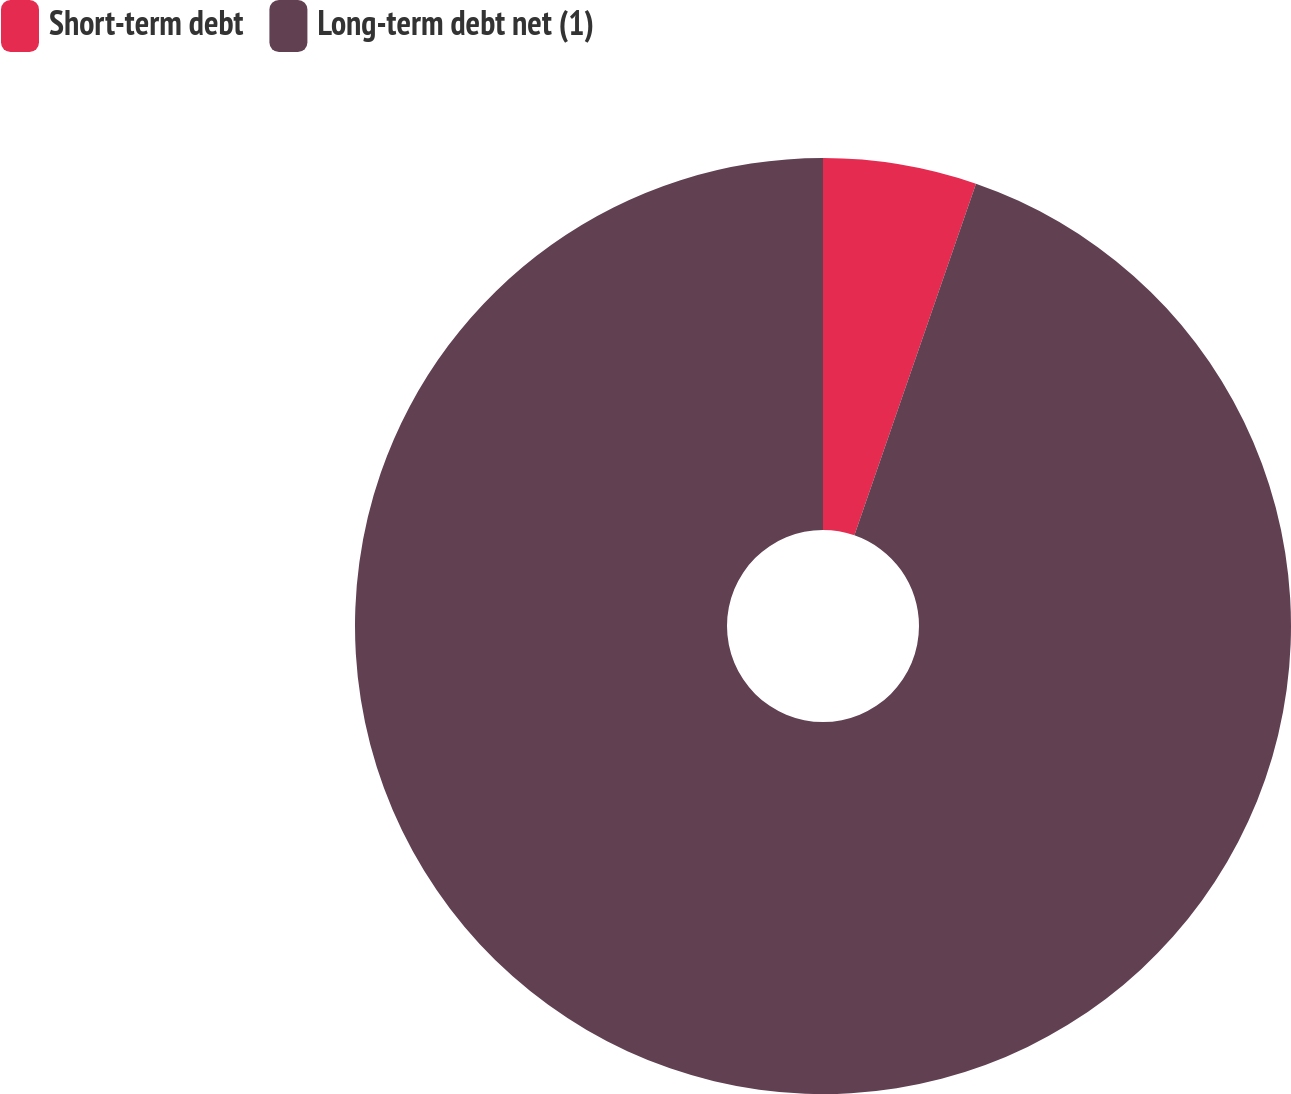Convert chart to OTSL. <chart><loc_0><loc_0><loc_500><loc_500><pie_chart><fcel>Short-term debt<fcel>Long-term debt net (1)<nl><fcel>5.3%<fcel>94.7%<nl></chart> 